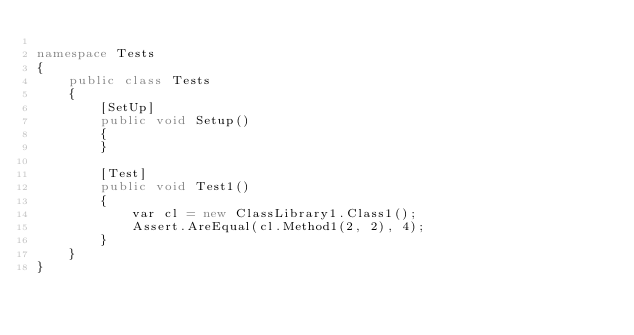Convert code to text. <code><loc_0><loc_0><loc_500><loc_500><_C#_>
namespace Tests
{
    public class Tests
    {
        [SetUp]
        public void Setup()
        {
        }

        [Test]
        public void Test1()
        {
            var cl = new ClassLibrary1.Class1();
            Assert.AreEqual(cl.Method1(2, 2), 4);
        }
    }
}</code> 